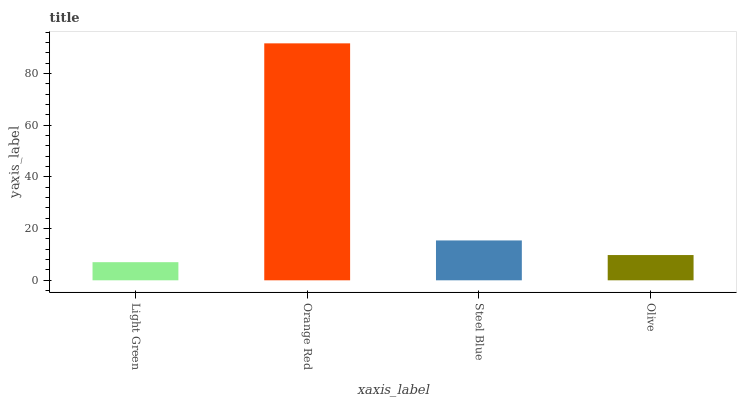Is Light Green the minimum?
Answer yes or no. Yes. Is Orange Red the maximum?
Answer yes or no. Yes. Is Steel Blue the minimum?
Answer yes or no. No. Is Steel Blue the maximum?
Answer yes or no. No. Is Orange Red greater than Steel Blue?
Answer yes or no. Yes. Is Steel Blue less than Orange Red?
Answer yes or no. Yes. Is Steel Blue greater than Orange Red?
Answer yes or no. No. Is Orange Red less than Steel Blue?
Answer yes or no. No. Is Steel Blue the high median?
Answer yes or no. Yes. Is Olive the low median?
Answer yes or no. Yes. Is Orange Red the high median?
Answer yes or no. No. Is Orange Red the low median?
Answer yes or no. No. 